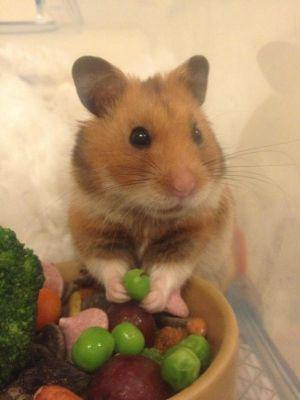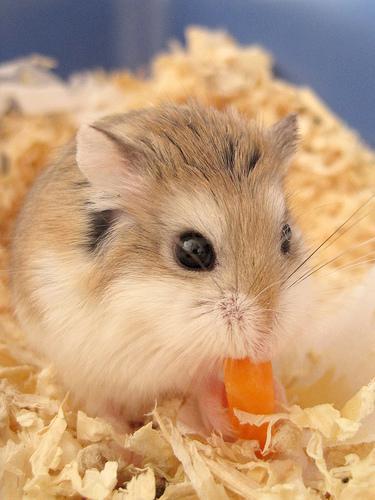The first image is the image on the left, the second image is the image on the right. For the images displayed, is the sentence "One image shows a pet rodent standing on a bed of shredded material." factually correct? Answer yes or no. Yes. 